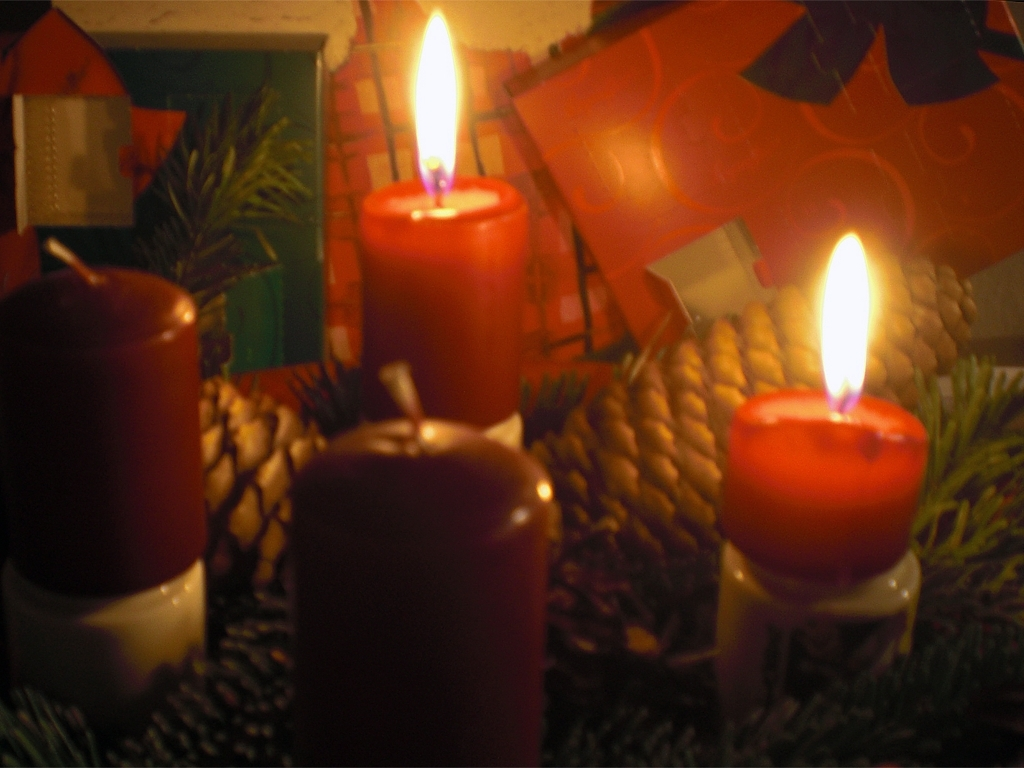Is the image clear? The picture quality is suboptimal due to noticeable blurring and low lighting, making it difficult to discern fine details clearly. 